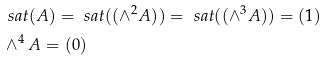<formula> <loc_0><loc_0><loc_500><loc_500>& \ s a t ( A ) = \ s a t ( ( \wedge ^ { 2 } A ) ) = \ s a t ( ( \wedge ^ { 3 } A ) ) = ( 1 ) \\ & \wedge ^ { 4 } A = ( 0 )</formula> 